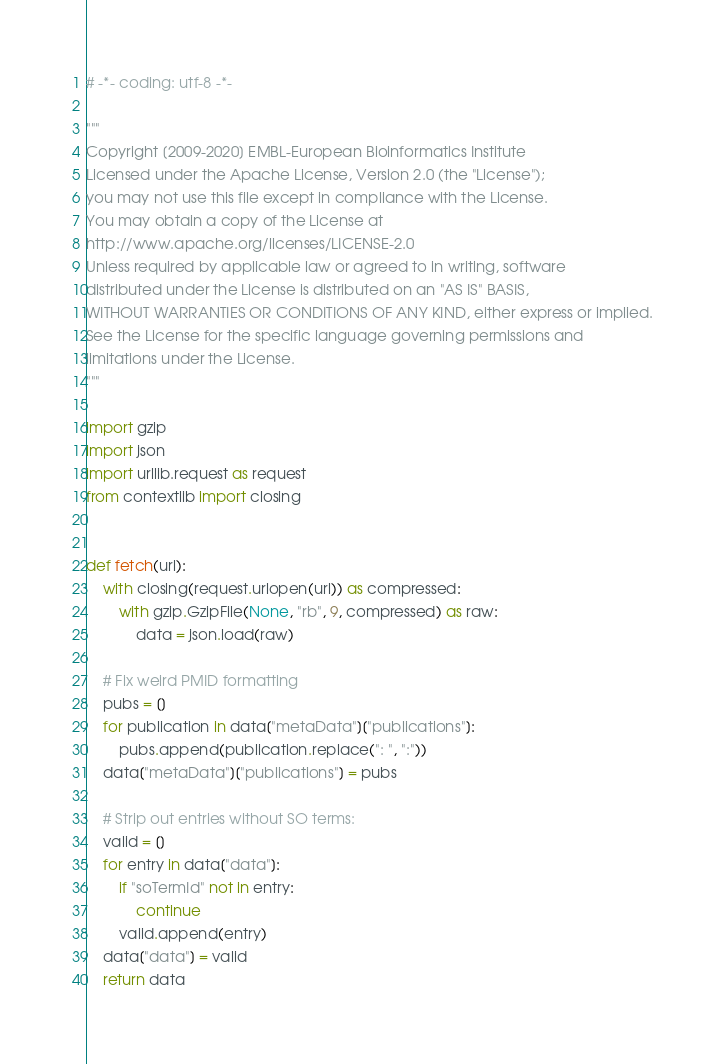Convert code to text. <code><loc_0><loc_0><loc_500><loc_500><_Python_># -*- coding: utf-8 -*-

"""
Copyright [2009-2020] EMBL-European Bioinformatics Institute
Licensed under the Apache License, Version 2.0 (the "License");
you may not use this file except in compliance with the License.
You may obtain a copy of the License at
http://www.apache.org/licenses/LICENSE-2.0
Unless required by applicable law or agreed to in writing, software
distributed under the License is distributed on an "AS IS" BASIS,
WITHOUT WARRANTIES OR CONDITIONS OF ANY KIND, either express or implied.
See the License for the specific language governing permissions and
limitations under the License.
"""

import gzip
import json
import urllib.request as request
from contextlib import closing


def fetch(url):
    with closing(request.urlopen(url)) as compressed:
        with gzip.GzipFile(None, "rb", 9, compressed) as raw:
            data = json.load(raw)

    # Fix weird PMID formatting
    pubs = []
    for publication in data["metaData"]["publications"]:
        pubs.append(publication.replace(": ", ":"))
    data["metaData"]["publications"] = pubs

    # Strip out entries without SO terms:
    valid = []
    for entry in data["data"]:
        if "soTermId" not in entry:
            continue
        valid.append(entry)
    data["data"] = valid
    return data
</code> 